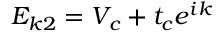<formula> <loc_0><loc_0><loc_500><loc_500>E _ { k 2 } = V _ { c } + t _ { c } e ^ { i k }</formula> 